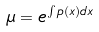Convert formula to latex. <formula><loc_0><loc_0><loc_500><loc_500>\mu = e ^ { \int p ( x ) d x }</formula> 